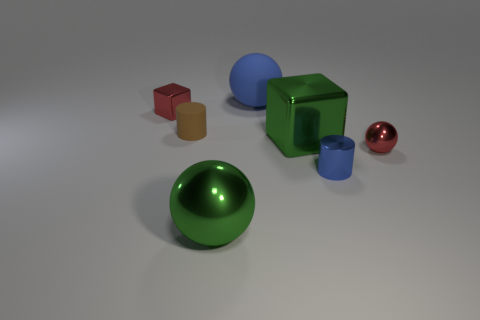Add 1 big cyan shiny cylinders. How many objects exist? 8 Subtract all cubes. How many objects are left? 5 Subtract 0 cyan blocks. How many objects are left? 7 Subtract all small matte cylinders. Subtract all yellow matte cylinders. How many objects are left? 6 Add 1 blue matte spheres. How many blue matte spheres are left? 2 Add 5 big yellow objects. How many big yellow objects exist? 5 